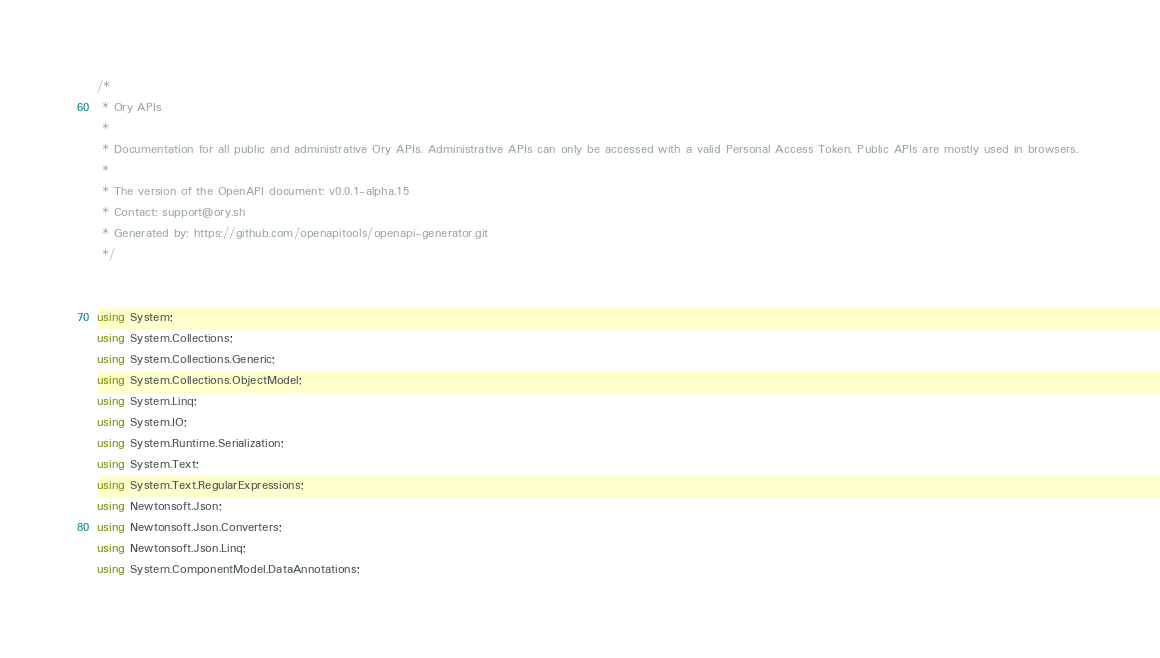<code> <loc_0><loc_0><loc_500><loc_500><_C#_>/*
 * Ory APIs
 *
 * Documentation for all public and administrative Ory APIs. Administrative APIs can only be accessed with a valid Personal Access Token. Public APIs are mostly used in browsers. 
 *
 * The version of the OpenAPI document: v0.0.1-alpha.15
 * Contact: support@ory.sh
 * Generated by: https://github.com/openapitools/openapi-generator.git
 */


using System;
using System.Collections;
using System.Collections.Generic;
using System.Collections.ObjectModel;
using System.Linq;
using System.IO;
using System.Runtime.Serialization;
using System.Text;
using System.Text.RegularExpressions;
using Newtonsoft.Json;
using Newtonsoft.Json.Converters;
using Newtonsoft.Json.Linq;
using System.ComponentModel.DataAnnotations;</code> 